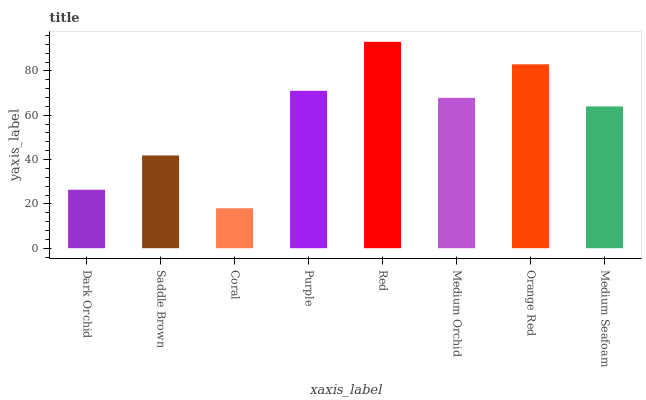Is Coral the minimum?
Answer yes or no. Yes. Is Red the maximum?
Answer yes or no. Yes. Is Saddle Brown the minimum?
Answer yes or no. No. Is Saddle Brown the maximum?
Answer yes or no. No. Is Saddle Brown greater than Dark Orchid?
Answer yes or no. Yes. Is Dark Orchid less than Saddle Brown?
Answer yes or no. Yes. Is Dark Orchid greater than Saddle Brown?
Answer yes or no. No. Is Saddle Brown less than Dark Orchid?
Answer yes or no. No. Is Medium Orchid the high median?
Answer yes or no. Yes. Is Medium Seafoam the low median?
Answer yes or no. Yes. Is Orange Red the high median?
Answer yes or no. No. Is Orange Red the low median?
Answer yes or no. No. 